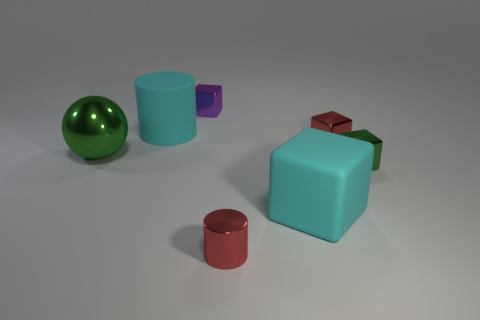What is the texture of the objects on the far left? The objects on the far left, a large green metallic ball and a small matte aqua cylinder, have distinct textures. The ball has a shiny, reflective surface suggestive of a polished metal, while the cylinder appears to have a more diffused, matte finish. 